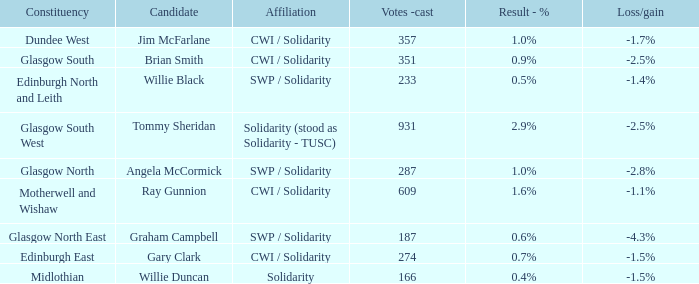What was the loss/gain when the alliance was cohesion? -1.5%. 